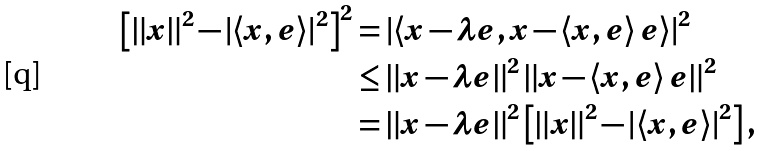Convert formula to latex. <formula><loc_0><loc_0><loc_500><loc_500>\left [ \left \| x \right \| ^ { 2 } - \left | \left \langle x , e \right \rangle \right | ^ { 2 } \right ] ^ { 2 } & = \left | \left \langle x - \lambda e , x - \left \langle x , e \right \rangle e \right \rangle \right | ^ { 2 } \\ & \leq \left \| x - \lambda e \right \| ^ { 2 } \left \| x - \left \langle x , e \right \rangle e \right \| ^ { 2 } \\ & = \left \| x - \lambda e \right \| ^ { 2 } \left [ \left \| x \right \| ^ { 2 } - \left | \left \langle x , e \right \rangle \right | ^ { 2 } \right ] ,</formula> 